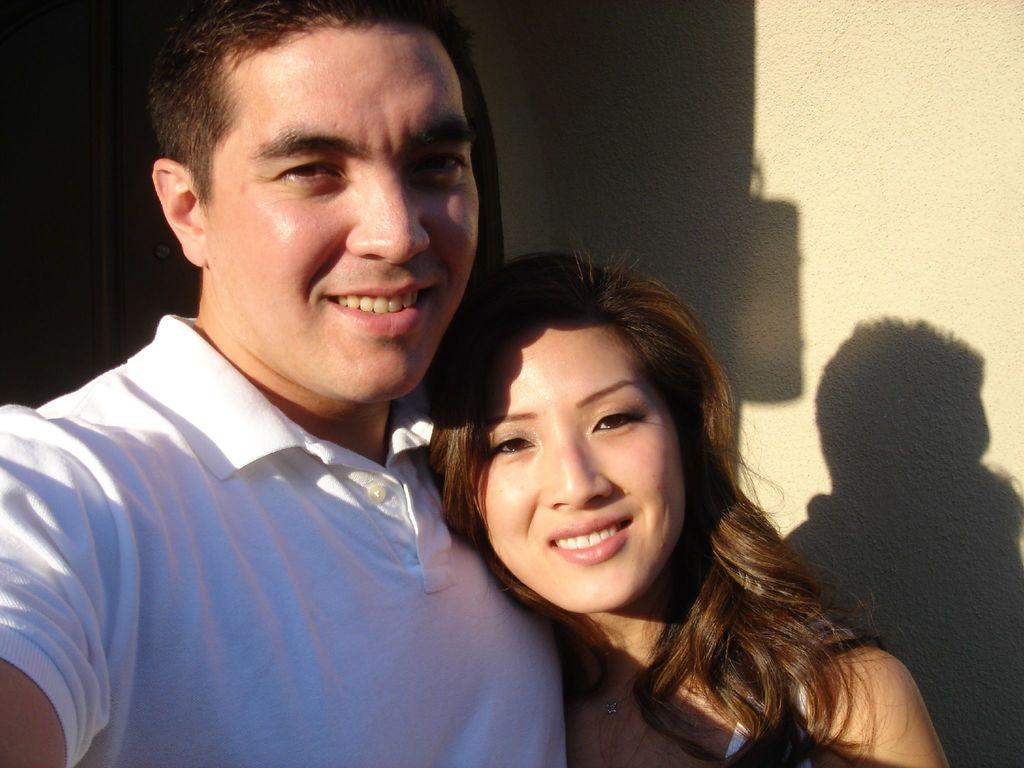Who are the people in the image? There is a man and a woman in the image. Where are the man and woman located in the image? The man and woman are in the center of the image. What type of lock can be seen on the road in the image? There is no lock or road present in the image; it features a man and a woman in the center. 